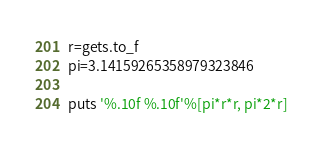<code> <loc_0><loc_0><loc_500><loc_500><_Ruby_>r=gets.to_f
pi=3.14159265358979323846
 
puts '%.10f %.10f'%[pi*r*r, pi*2*r]</code> 